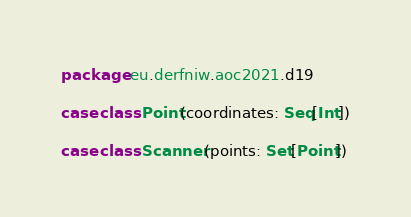<code> <loc_0><loc_0><loc_500><loc_500><_Scala_>package eu.derfniw.aoc2021.d19

case class Point(coordinates: Seq[Int])

case class Scanner(points: Set[Point])
</code> 